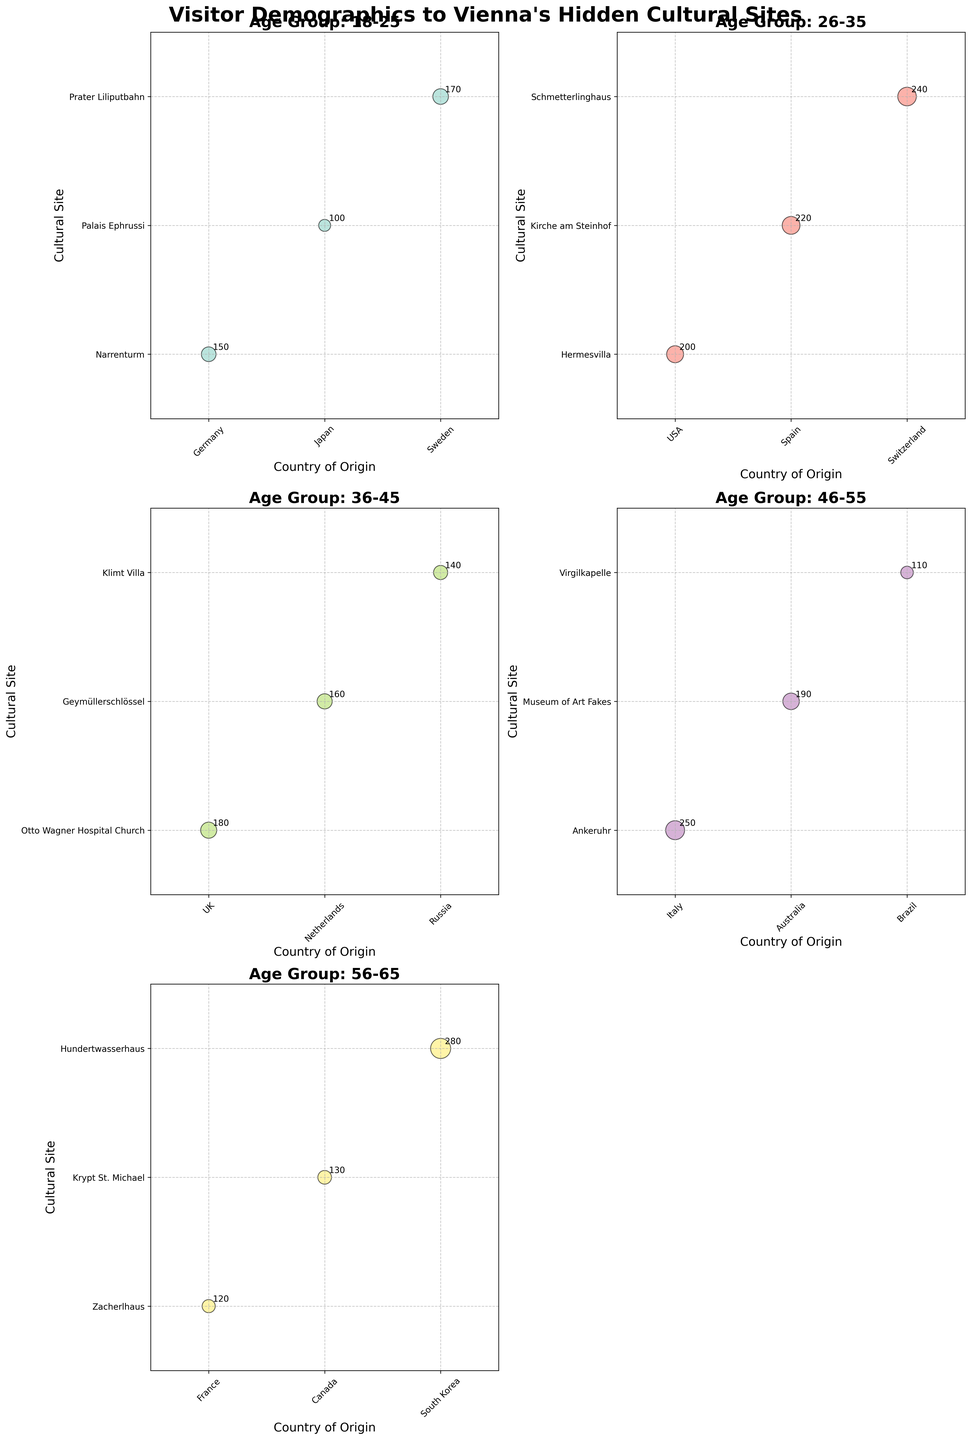How many age groups are represented in the figure? Count the unique 'Age Group' subplots. There are subplots for 18-25, 26-35, 36-45, 46-55, and 56-65 age groups.
Answer: 5 Which cultural site received the highest number of visitors from the 46-55 age group? Look at the subplot for the 46-55 age group and find the largest bubble, marked as '250', which corresponds to the Ankeruhr site with visitors from Italy.
Answer: Ankeruhr In the 26-35 age group, which country of origin sent the most visitors to Vienna's hidden cultural sites? In the subplot for the 26-35 age group, identify the largest circles and check their labels. The highest number (240 visitors) corresponds to Switzerland.
Answer: Switzerland Which age group had the most visitors to the site Hundertwasserhaus? Locate the Hundertwasserhaus on its respective subplot. The size '280' appears under the 56-65 age group.
Answer: 56-65 Which two sites received the least visitors from the 36-45 age group? In the 36-45 age group subplot, identify the two smallest bubbles, marked with 140 (Klimt Villa) and 160 (Geymüllerschlössel).
Answer: Klimt Villa, Geymüllerschlössel On average, how many visitors are there in the 18-25 age group? Sum the visitors in the 18-25 group (150 + 100 + 170) and divide by the number of countries (3). The average is (150 + 100 + 170) / 3 = 140.
Answer: 140 Which country has the most distinct visitor representations across all age groups? Check which country appears most frequently across all the subplots. Each country's representation counts up to figure out that Germany, USA, etc., appear once each. No single country dominates.
Answer: None Are there any age groups where cultural sites have visitors from only one origin country? Check each subplot if it represents data from only one country. All age group subplots have visitors from multiple countries.
Answer: No 